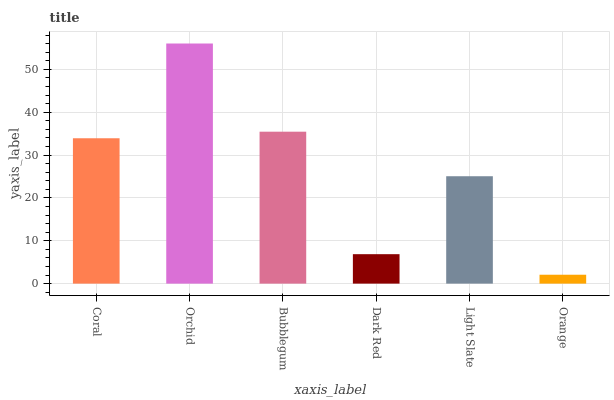Is Orange the minimum?
Answer yes or no. Yes. Is Orchid the maximum?
Answer yes or no. Yes. Is Bubblegum the minimum?
Answer yes or no. No. Is Bubblegum the maximum?
Answer yes or no. No. Is Orchid greater than Bubblegum?
Answer yes or no. Yes. Is Bubblegum less than Orchid?
Answer yes or no. Yes. Is Bubblegum greater than Orchid?
Answer yes or no. No. Is Orchid less than Bubblegum?
Answer yes or no. No. Is Coral the high median?
Answer yes or no. Yes. Is Light Slate the low median?
Answer yes or no. Yes. Is Orchid the high median?
Answer yes or no. No. Is Orange the low median?
Answer yes or no. No. 